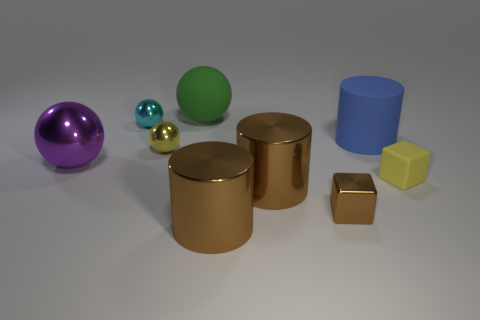Subtract all yellow spheres. How many spheres are left? 3 Subtract all purple spheres. How many spheres are left? 3 Subtract 2 cylinders. How many cylinders are left? 1 Subtract all spheres. How many objects are left? 5 Subtract all cyan blocks. How many blue cylinders are left? 1 Add 8 big purple cylinders. How many big purple cylinders exist? 8 Subtract 1 green spheres. How many objects are left? 8 Subtract all cyan cylinders. Subtract all purple cubes. How many cylinders are left? 3 Subtract all purple spheres. Subtract all yellow rubber spheres. How many objects are left? 8 Add 9 brown cubes. How many brown cubes are left? 10 